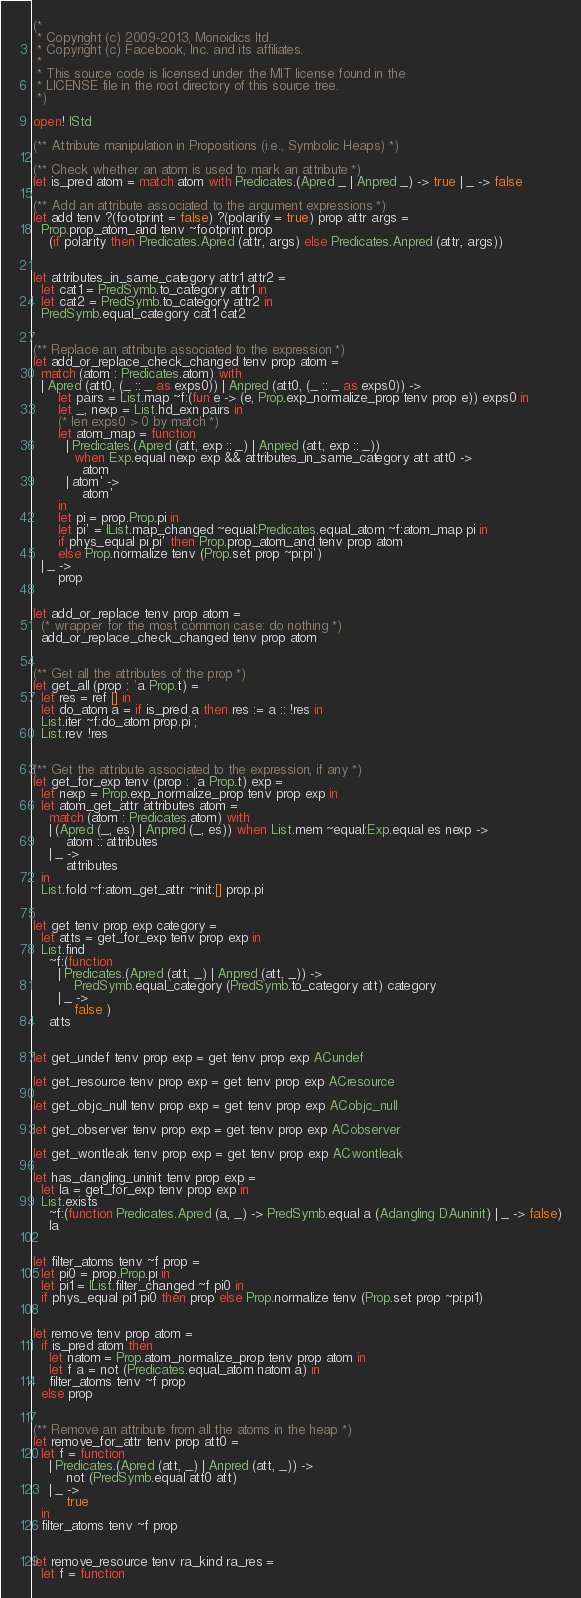Convert code to text. <code><loc_0><loc_0><loc_500><loc_500><_OCaml_>(*
 * Copyright (c) 2009-2013, Monoidics ltd.
 * Copyright (c) Facebook, Inc. and its affiliates.
 *
 * This source code is licensed under the MIT license found in the
 * LICENSE file in the root directory of this source tree.
 *)

open! IStd

(** Attribute manipulation in Propositions (i.e., Symbolic Heaps) *)

(** Check whether an atom is used to mark an attribute *)
let is_pred atom = match atom with Predicates.(Apred _ | Anpred _) -> true | _ -> false

(** Add an attribute associated to the argument expressions *)
let add tenv ?(footprint = false) ?(polarity = true) prop attr args =
  Prop.prop_atom_and tenv ~footprint prop
    (if polarity then Predicates.Apred (attr, args) else Predicates.Anpred (attr, args))


let attributes_in_same_category attr1 attr2 =
  let cat1 = PredSymb.to_category attr1 in
  let cat2 = PredSymb.to_category attr2 in
  PredSymb.equal_category cat1 cat2


(** Replace an attribute associated to the expression *)
let add_or_replace_check_changed tenv prop atom =
  match (atom : Predicates.atom) with
  | Apred (att0, (_ :: _ as exps0)) | Anpred (att0, (_ :: _ as exps0)) ->
      let pairs = List.map ~f:(fun e -> (e, Prop.exp_normalize_prop tenv prop e)) exps0 in
      let _, nexp = List.hd_exn pairs in
      (* len exps0 > 0 by match *)
      let atom_map = function
        | Predicates.(Apred (att, exp :: _) | Anpred (att, exp :: _))
          when Exp.equal nexp exp && attributes_in_same_category att att0 ->
            atom
        | atom' ->
            atom'
      in
      let pi = prop.Prop.pi in
      let pi' = IList.map_changed ~equal:Predicates.equal_atom ~f:atom_map pi in
      if phys_equal pi pi' then Prop.prop_atom_and tenv prop atom
      else Prop.normalize tenv (Prop.set prop ~pi:pi')
  | _ ->
      prop


let add_or_replace tenv prop atom =
  (* wrapper for the most common case: do nothing *)
  add_or_replace_check_changed tenv prop atom


(** Get all the attributes of the prop *)
let get_all (prop : 'a Prop.t) =
  let res = ref [] in
  let do_atom a = if is_pred a then res := a :: !res in
  List.iter ~f:do_atom prop.pi ;
  List.rev !res


(** Get the attribute associated to the expression, if any *)
let get_for_exp tenv (prop : 'a Prop.t) exp =
  let nexp = Prop.exp_normalize_prop tenv prop exp in
  let atom_get_attr attributes atom =
    match (atom : Predicates.atom) with
    | (Apred (_, es) | Anpred (_, es)) when List.mem ~equal:Exp.equal es nexp ->
        atom :: attributes
    | _ ->
        attributes
  in
  List.fold ~f:atom_get_attr ~init:[] prop.pi


let get tenv prop exp category =
  let atts = get_for_exp tenv prop exp in
  List.find
    ~f:(function
      | Predicates.(Apred (att, _) | Anpred (att, _)) ->
          PredSymb.equal_category (PredSymb.to_category att) category
      | _ ->
          false )
    atts


let get_undef tenv prop exp = get tenv prop exp ACundef

let get_resource tenv prop exp = get tenv prop exp ACresource

let get_objc_null tenv prop exp = get tenv prop exp ACobjc_null

let get_observer tenv prop exp = get tenv prop exp ACobserver

let get_wontleak tenv prop exp = get tenv prop exp ACwontleak

let has_dangling_uninit tenv prop exp =
  let la = get_for_exp tenv prop exp in
  List.exists
    ~f:(function Predicates.Apred (a, _) -> PredSymb.equal a (Adangling DAuninit) | _ -> false)
    la


let filter_atoms tenv ~f prop =
  let pi0 = prop.Prop.pi in
  let pi1 = IList.filter_changed ~f pi0 in
  if phys_equal pi1 pi0 then prop else Prop.normalize tenv (Prop.set prop ~pi:pi1)


let remove tenv prop atom =
  if is_pred atom then
    let natom = Prop.atom_normalize_prop tenv prop atom in
    let f a = not (Predicates.equal_atom natom a) in
    filter_atoms tenv ~f prop
  else prop


(** Remove an attribute from all the atoms in the heap *)
let remove_for_attr tenv prop att0 =
  let f = function
    | Predicates.(Apred (att, _) | Anpred (att, _)) ->
        not (PredSymb.equal att0 att)
    | _ ->
        true
  in
  filter_atoms tenv ~f prop


let remove_resource tenv ra_kind ra_res =
  let f = function</code> 